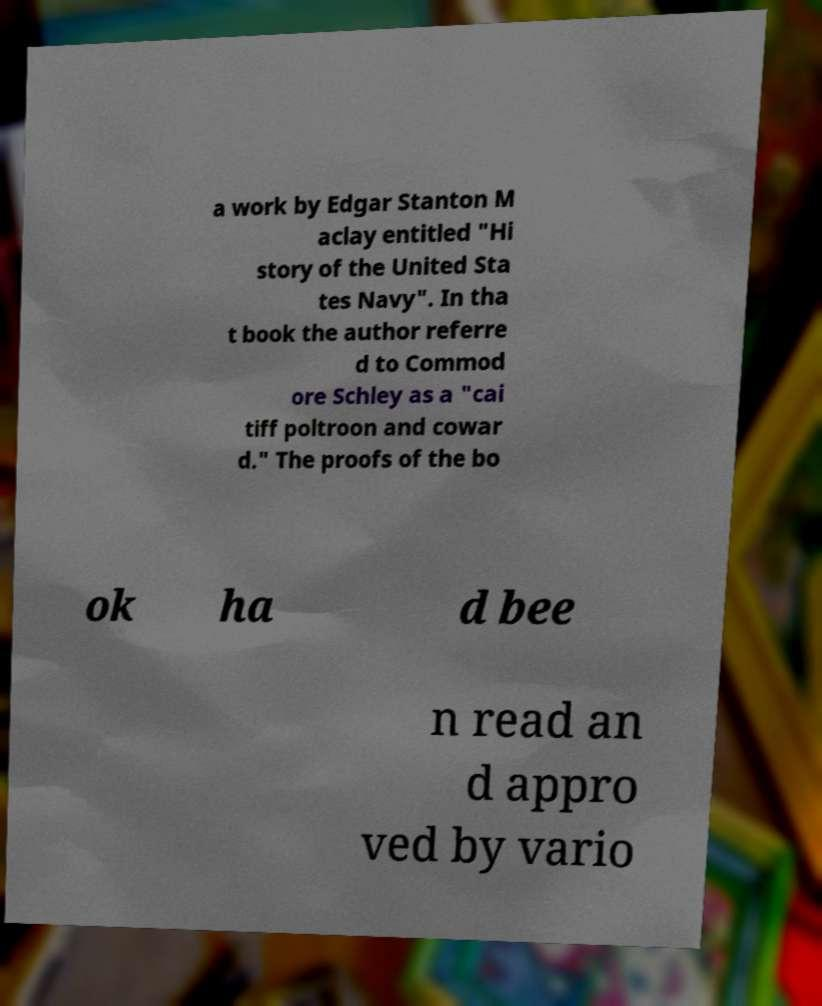There's text embedded in this image that I need extracted. Can you transcribe it verbatim? a work by Edgar Stanton M aclay entitled "Hi story of the United Sta tes Navy". In tha t book the author referre d to Commod ore Schley as a "cai tiff poltroon and cowar d." The proofs of the bo ok ha d bee n read an d appro ved by vario 